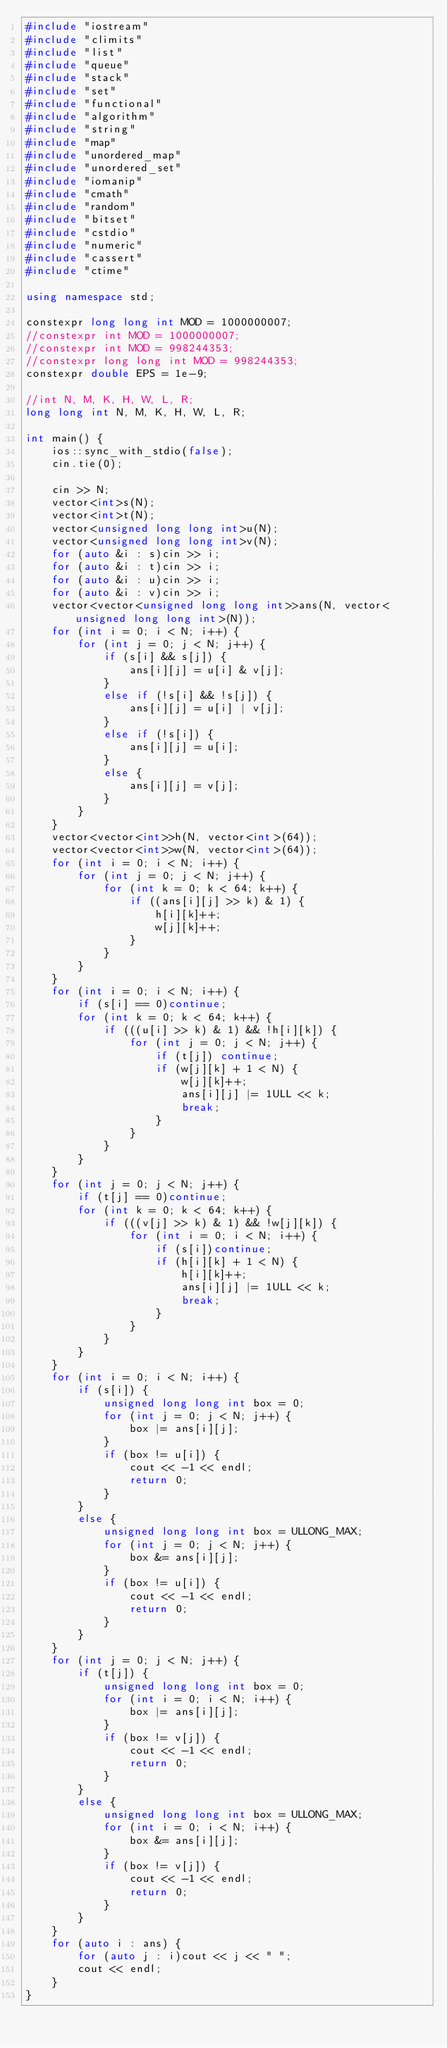Convert code to text. <code><loc_0><loc_0><loc_500><loc_500><_C++_>#include "iostream"
#include "climits"
#include "list"
#include "queue"
#include "stack"
#include "set"
#include "functional"
#include "algorithm"
#include "string"
#include "map"
#include "unordered_map"
#include "unordered_set"
#include "iomanip"
#include "cmath"
#include "random"
#include "bitset"
#include "cstdio"
#include "numeric"
#include "cassert"
#include "ctime"

using namespace std;

constexpr long long int MOD = 1000000007;
//constexpr int MOD = 1000000007;
//constexpr int MOD = 998244353;
//constexpr long long int MOD = 998244353;
constexpr double EPS = 1e-9;

//int N, M, K, H, W, L, R;
long long int N, M, K, H, W, L, R;

int main() {
	ios::sync_with_stdio(false);
	cin.tie(0);

	cin >> N;
	vector<int>s(N);
	vector<int>t(N);
	vector<unsigned long long int>u(N);
	vector<unsigned long long int>v(N);
	for (auto &i : s)cin >> i;
	for (auto &i : t)cin >> i;
	for (auto &i : u)cin >> i;
	for (auto &i : v)cin >> i;
	vector<vector<unsigned long long int>>ans(N, vector<unsigned long long int>(N));
	for (int i = 0; i < N; i++) {
		for (int j = 0; j < N; j++) {
			if (s[i] && s[j]) {
				ans[i][j] = u[i] & v[j];
			}
			else if (!s[i] && !s[j]) {
				ans[i][j] = u[i] | v[j];
			}
			else if (!s[i]) {
				ans[i][j] = u[i];
			}
			else {
				ans[i][j] = v[j];
			}
		}
	}
	vector<vector<int>>h(N, vector<int>(64));
	vector<vector<int>>w(N, vector<int>(64));
	for (int i = 0; i < N; i++) {
		for (int j = 0; j < N; j++) {
			for (int k = 0; k < 64; k++) {
				if ((ans[i][j] >> k) & 1) {
					h[i][k]++;
					w[j][k]++;
				}
			}
		}
	}
	for (int i = 0; i < N; i++) {
		if (s[i] == 0)continue;
		for (int k = 0; k < 64; k++) {
			if (((u[i] >> k) & 1) && !h[i][k]) {
				for (int j = 0; j < N; j++) {
					if (t[j]) continue;
					if (w[j][k] + 1 < N) {
						w[j][k]++;
						ans[i][j] |= 1ULL << k;
						break;
					}
				}
			}
		}
	}
	for (int j = 0; j < N; j++) {
		if (t[j] == 0)continue;
		for (int k = 0; k < 64; k++) {
			if (((v[j] >> k) & 1) && !w[j][k]) {
				for (int i = 0; i < N; i++) {
					if (s[i])continue;
					if (h[i][k] + 1 < N) {
						h[i][k]++;
						ans[i][j] |= 1ULL << k;
						break;
					}
				}
			}
		}
	}
	for (int i = 0; i < N; i++) {
		if (s[i]) {
			unsigned long long int box = 0;
			for (int j = 0; j < N; j++) {
				box |= ans[i][j];
			}
			if (box != u[i]) {
				cout << -1 << endl;
				return 0;
			}
		}
		else {
			unsigned long long int box = ULLONG_MAX;
			for (int j = 0; j < N; j++) {
				box &= ans[i][j];
			}
			if (box != u[i]) {
				cout << -1 << endl;
				return 0;
			}
		}
	}
	for (int j = 0; j < N; j++) {
		if (t[j]) {
			unsigned long long int box = 0;
			for (int i = 0; i < N; i++) {
				box |= ans[i][j];
			}
			if (box != v[j]) {
				cout << -1 << endl;
				return 0;
			}
		}
		else {
			unsigned long long int box = ULLONG_MAX;
			for (int i = 0; i < N; i++) {
				box &= ans[i][j];
			}
			if (box != v[j]) {
				cout << -1 << endl;
				return 0;
			}
		}
	}
	for (auto i : ans) {
		for (auto j : i)cout << j << " ";
		cout << endl;
	}
}
</code> 